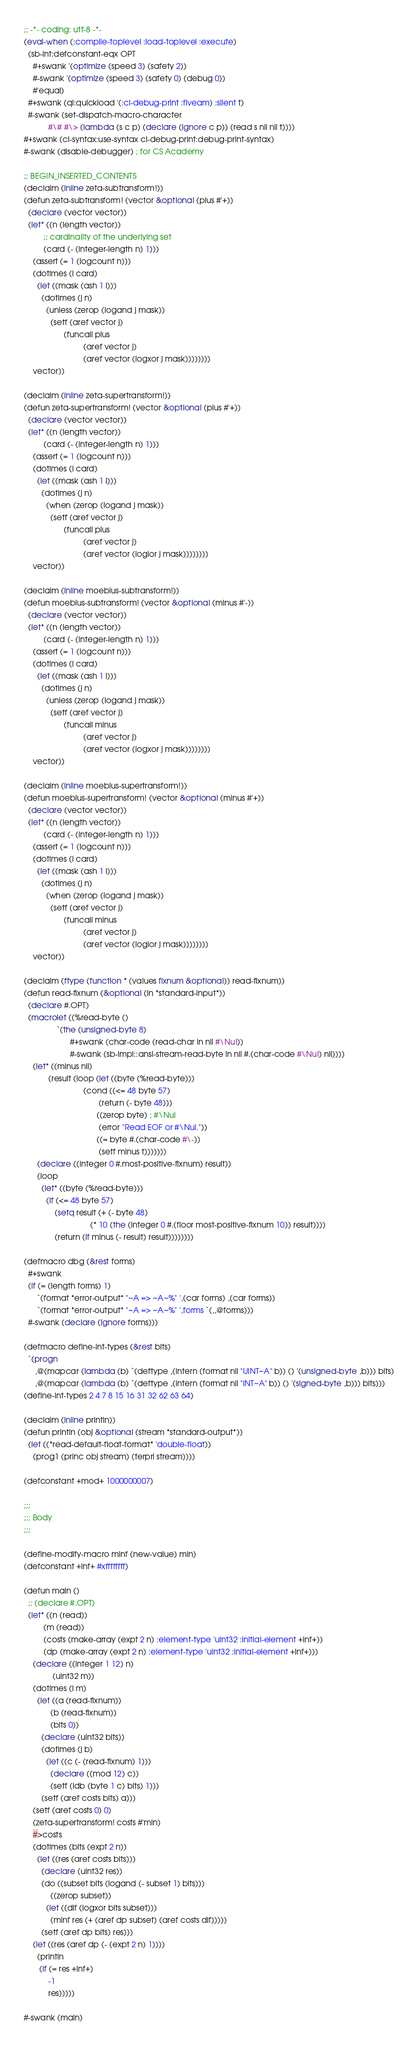<code> <loc_0><loc_0><loc_500><loc_500><_Lisp_>;; -*- coding: utf-8 -*-
(eval-when (:compile-toplevel :load-toplevel :execute)
  (sb-int:defconstant-eqx OPT
    #+swank '(optimize (speed 3) (safety 2))
    #-swank '(optimize (speed 3) (safety 0) (debug 0))
    #'equal)
  #+swank (ql:quickload '(:cl-debug-print :fiveam) :silent t)
  #-swank (set-dispatch-macro-character
           #\# #\> (lambda (s c p) (declare (ignore c p)) (read s nil nil t))))
#+swank (cl-syntax:use-syntax cl-debug-print:debug-print-syntax)
#-swank (disable-debugger) ; for CS Academy

;; BEGIN_INSERTED_CONTENTS
(declaim (inline zeta-subtransform!))
(defun zeta-subtransform! (vector &optional (plus #'+))
  (declare (vector vector))
  (let* ((n (length vector))
         ;; cardinality of the underlying set
         (card (- (integer-length n) 1)))
    (assert (= 1 (logcount n)))
    (dotimes (i card)
      (let ((mask (ash 1 i)))
        (dotimes (j n)
          (unless (zerop (logand j mask))
            (setf (aref vector j)
                  (funcall plus
                           (aref vector j)
                           (aref vector (logxor j mask))))))))
    vector))

(declaim (inline zeta-supertransform!))
(defun zeta-supertransform! (vector &optional (plus #'+))
  (declare (vector vector))
  (let* ((n (length vector))
         (card (- (integer-length n) 1)))
    (assert (= 1 (logcount n)))
    (dotimes (i card)
      (let ((mask (ash 1 i)))
        (dotimes (j n)
          (when (zerop (logand j mask))
            (setf (aref vector j)
                  (funcall plus
                           (aref vector j)
                           (aref vector (logior j mask))))))))
    vector))

(declaim (inline moebius-subtransform!))
(defun moebius-subtransform! (vector &optional (minus #'-))
  (declare (vector vector))
  (let* ((n (length vector))
         (card (- (integer-length n) 1)))
    (assert (= 1 (logcount n)))
    (dotimes (i card)
      (let ((mask (ash 1 i)))
        (dotimes (j n)
          (unless (zerop (logand j mask))
            (setf (aref vector j)
                  (funcall minus
                           (aref vector j)
                           (aref vector (logxor j mask))))))))
    vector))

(declaim (inline moebius-supertransform!))
(defun moebius-supertransform! (vector &optional (minus #'+))
  (declare (vector vector))
  (let* ((n (length vector))
         (card (- (integer-length n) 1)))
    (assert (= 1 (logcount n)))
    (dotimes (i card)
      (let ((mask (ash 1 i)))
        (dotimes (j n)
          (when (zerop (logand j mask))
            (setf (aref vector j)
                  (funcall minus
                           (aref vector j)
                           (aref vector (logior j mask))))))))
    vector))

(declaim (ftype (function * (values fixnum &optional)) read-fixnum))
(defun read-fixnum (&optional (in *standard-input*))
  (declare #.OPT)
  (macrolet ((%read-byte ()
               `(the (unsigned-byte 8)
                     #+swank (char-code (read-char in nil #\Nul))
                     #-swank (sb-impl::ansi-stream-read-byte in nil #.(char-code #\Nul) nil))))
    (let* ((minus nil)
           (result (loop (let ((byte (%read-byte)))
                           (cond ((<= 48 byte 57)
                                  (return (- byte 48)))
                                 ((zerop byte) ; #\Nul
                                  (error "Read EOF or #\Nul."))
                                 ((= byte #.(char-code #\-))
                                  (setf minus t)))))))
      (declare ((integer 0 #.most-positive-fixnum) result))
      (loop
        (let* ((byte (%read-byte)))
          (if (<= 48 byte 57)
              (setq result (+ (- byte 48)
                              (* 10 (the (integer 0 #.(floor most-positive-fixnum 10)) result))))
              (return (if minus (- result) result))))))))

(defmacro dbg (&rest forms)
  #+swank
  (if (= (length forms) 1)
      `(format *error-output* "~A => ~A~%" ',(car forms) ,(car forms))
      `(format *error-output* "~A => ~A~%" ',forms `(,,@forms)))
  #-swank (declare (ignore forms)))

(defmacro define-int-types (&rest bits)
  `(progn
     ,@(mapcar (lambda (b) `(deftype ,(intern (format nil "UINT~A" b)) () '(unsigned-byte ,b))) bits)
     ,@(mapcar (lambda (b) `(deftype ,(intern (format nil "INT~A" b)) () '(signed-byte ,b))) bits)))
(define-int-types 2 4 7 8 15 16 31 32 62 63 64)

(declaim (inline println))
(defun println (obj &optional (stream *standard-output*))
  (let ((*read-default-float-format* 'double-float))
    (prog1 (princ obj stream) (terpri stream))))

(defconstant +mod+ 1000000007)

;;;
;;; Body
;;;

(define-modify-macro minf (new-value) min)
(defconstant +inf+ #xffffffff)

(defun main ()
  ;; (declare #.OPT)
  (let* ((n (read))
         (m (read))
         (costs (make-array (expt 2 n) :element-type 'uint32 :initial-element +inf+))
         (dp (make-array (expt 2 n) :element-type 'uint32 :initial-element +inf+)))
    (declare ((integer 1 12) n)
             (uint32 m))
    (dotimes (i m)
      (let ((a (read-fixnum))
            (b (read-fixnum))
            (bits 0))
        (declare (uint32 bits))
        (dotimes (j b)
          (let ((c (- (read-fixnum) 1)))
            (declare ((mod 12) c))
            (setf (ldb (byte 1 c) bits) 1)))
        (setf (aref costs bits) a)))
    (setf (aref costs 0) 0)
    (zeta-supertransform! costs #'min)
    #>costs
    (dotimes (bits (expt 2 n))
      (let ((res (aref costs bits)))
        (declare (uint32 res))
        (do ((subset bits (logand (- subset 1) bits)))
            ((zerop subset))
          (let ((dif (logxor bits subset)))
            (minf res (+ (aref dp subset) (aref costs dif)))))
        (setf (aref dp bits) res)))
    (let ((res (aref dp (- (expt 2 n) 1))))
      (println
       (if (= res +inf+)
           -1
           res)))))

#-swank (main)
</code> 